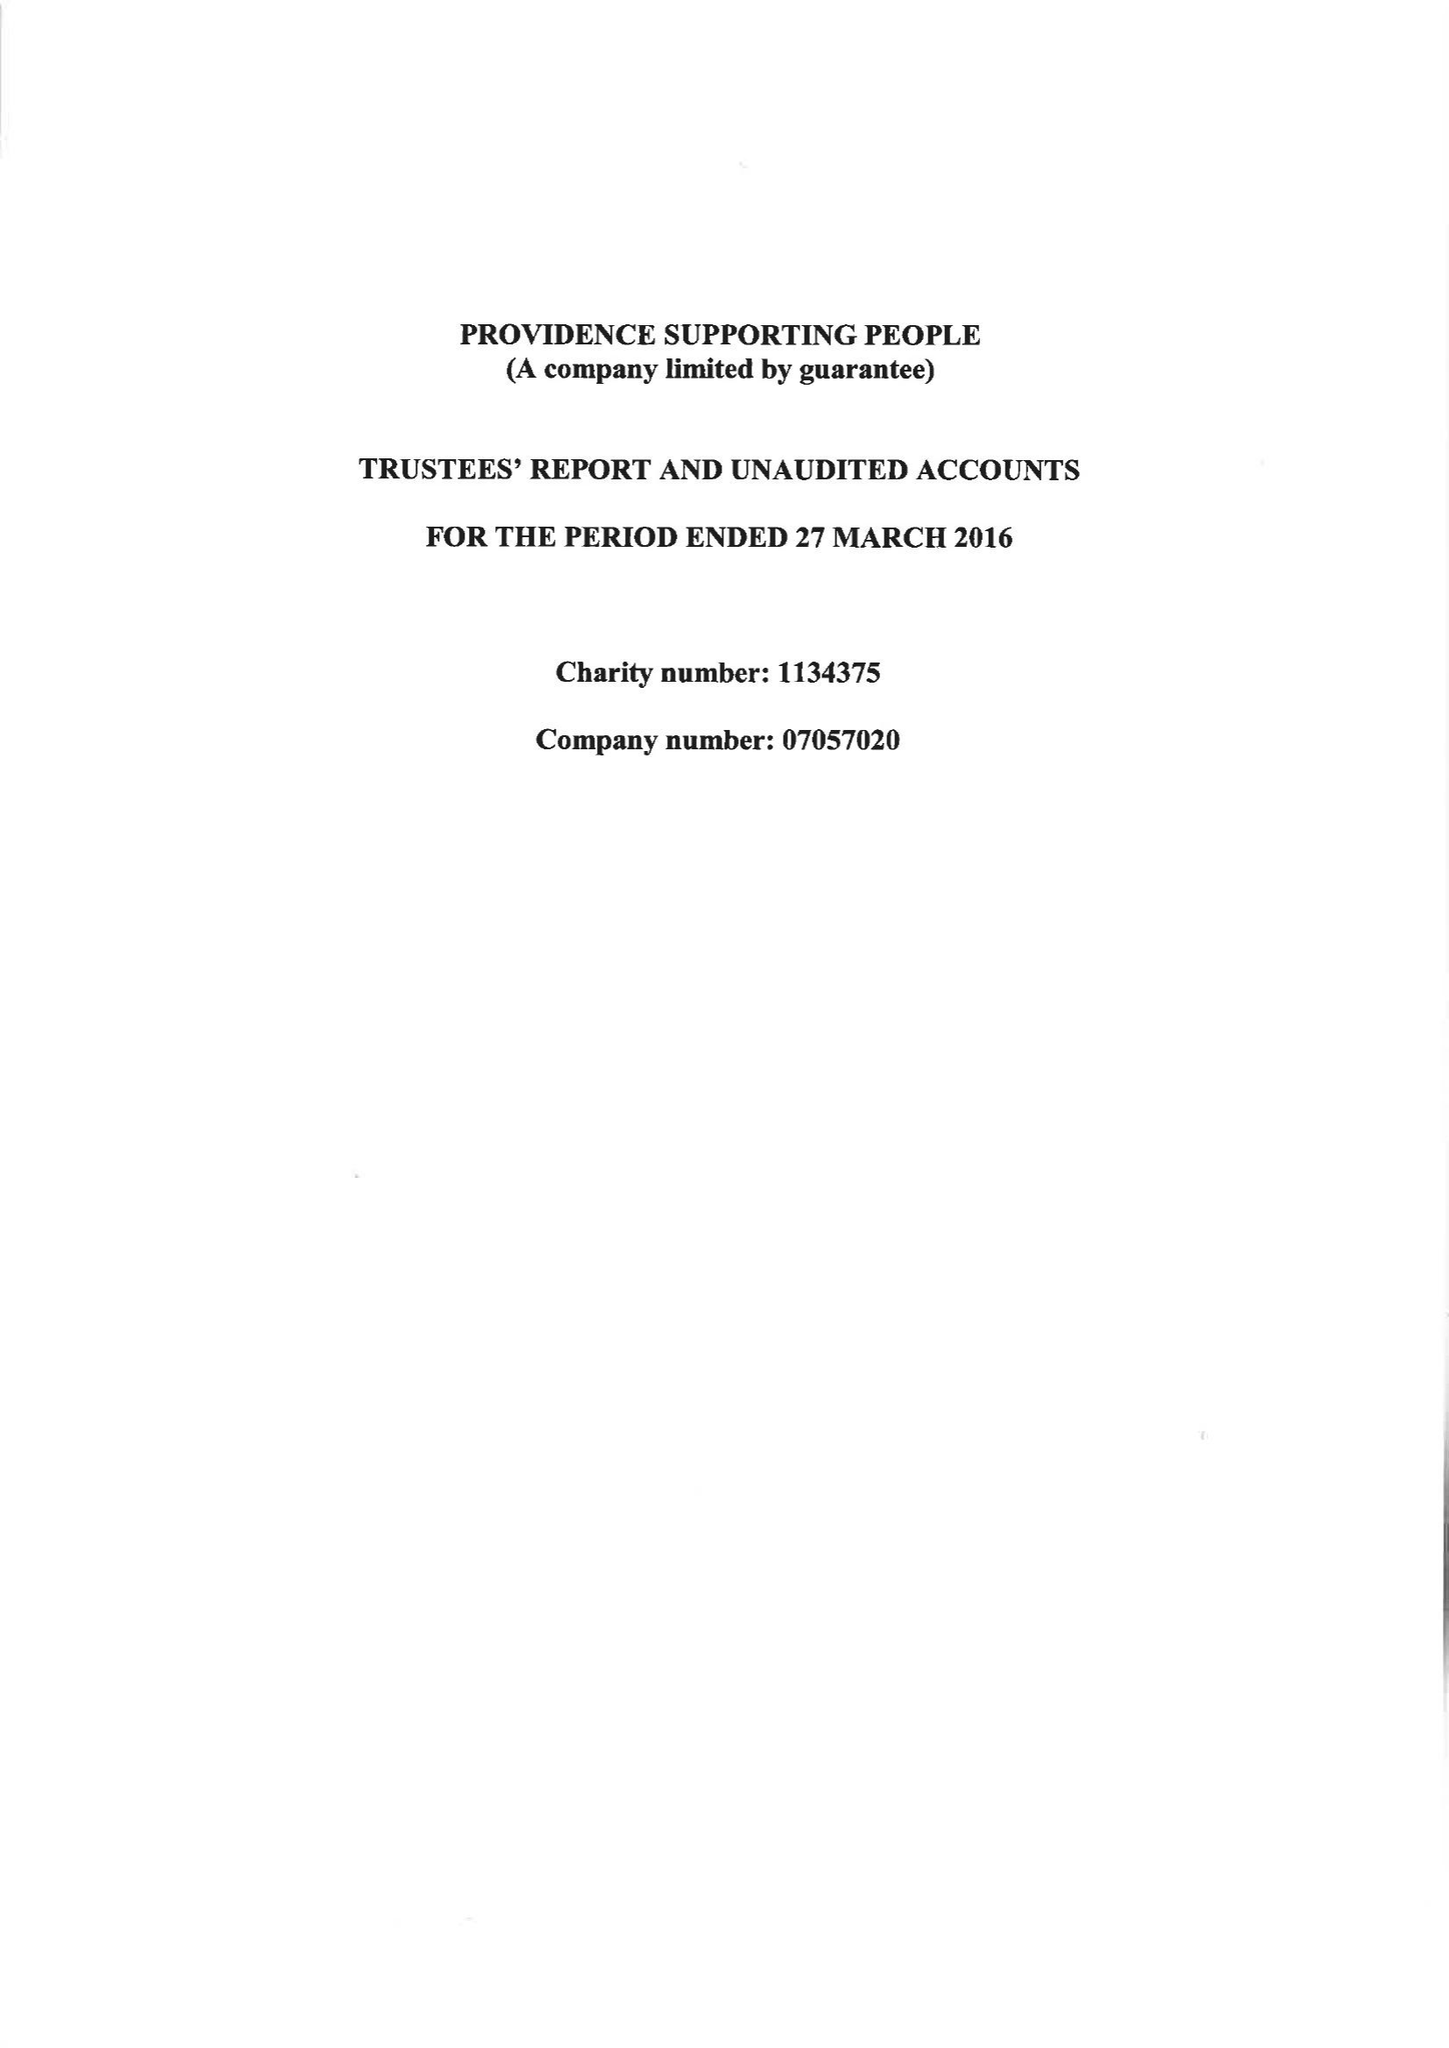What is the value for the report_date?
Answer the question using a single word or phrase. 2016-03-27 